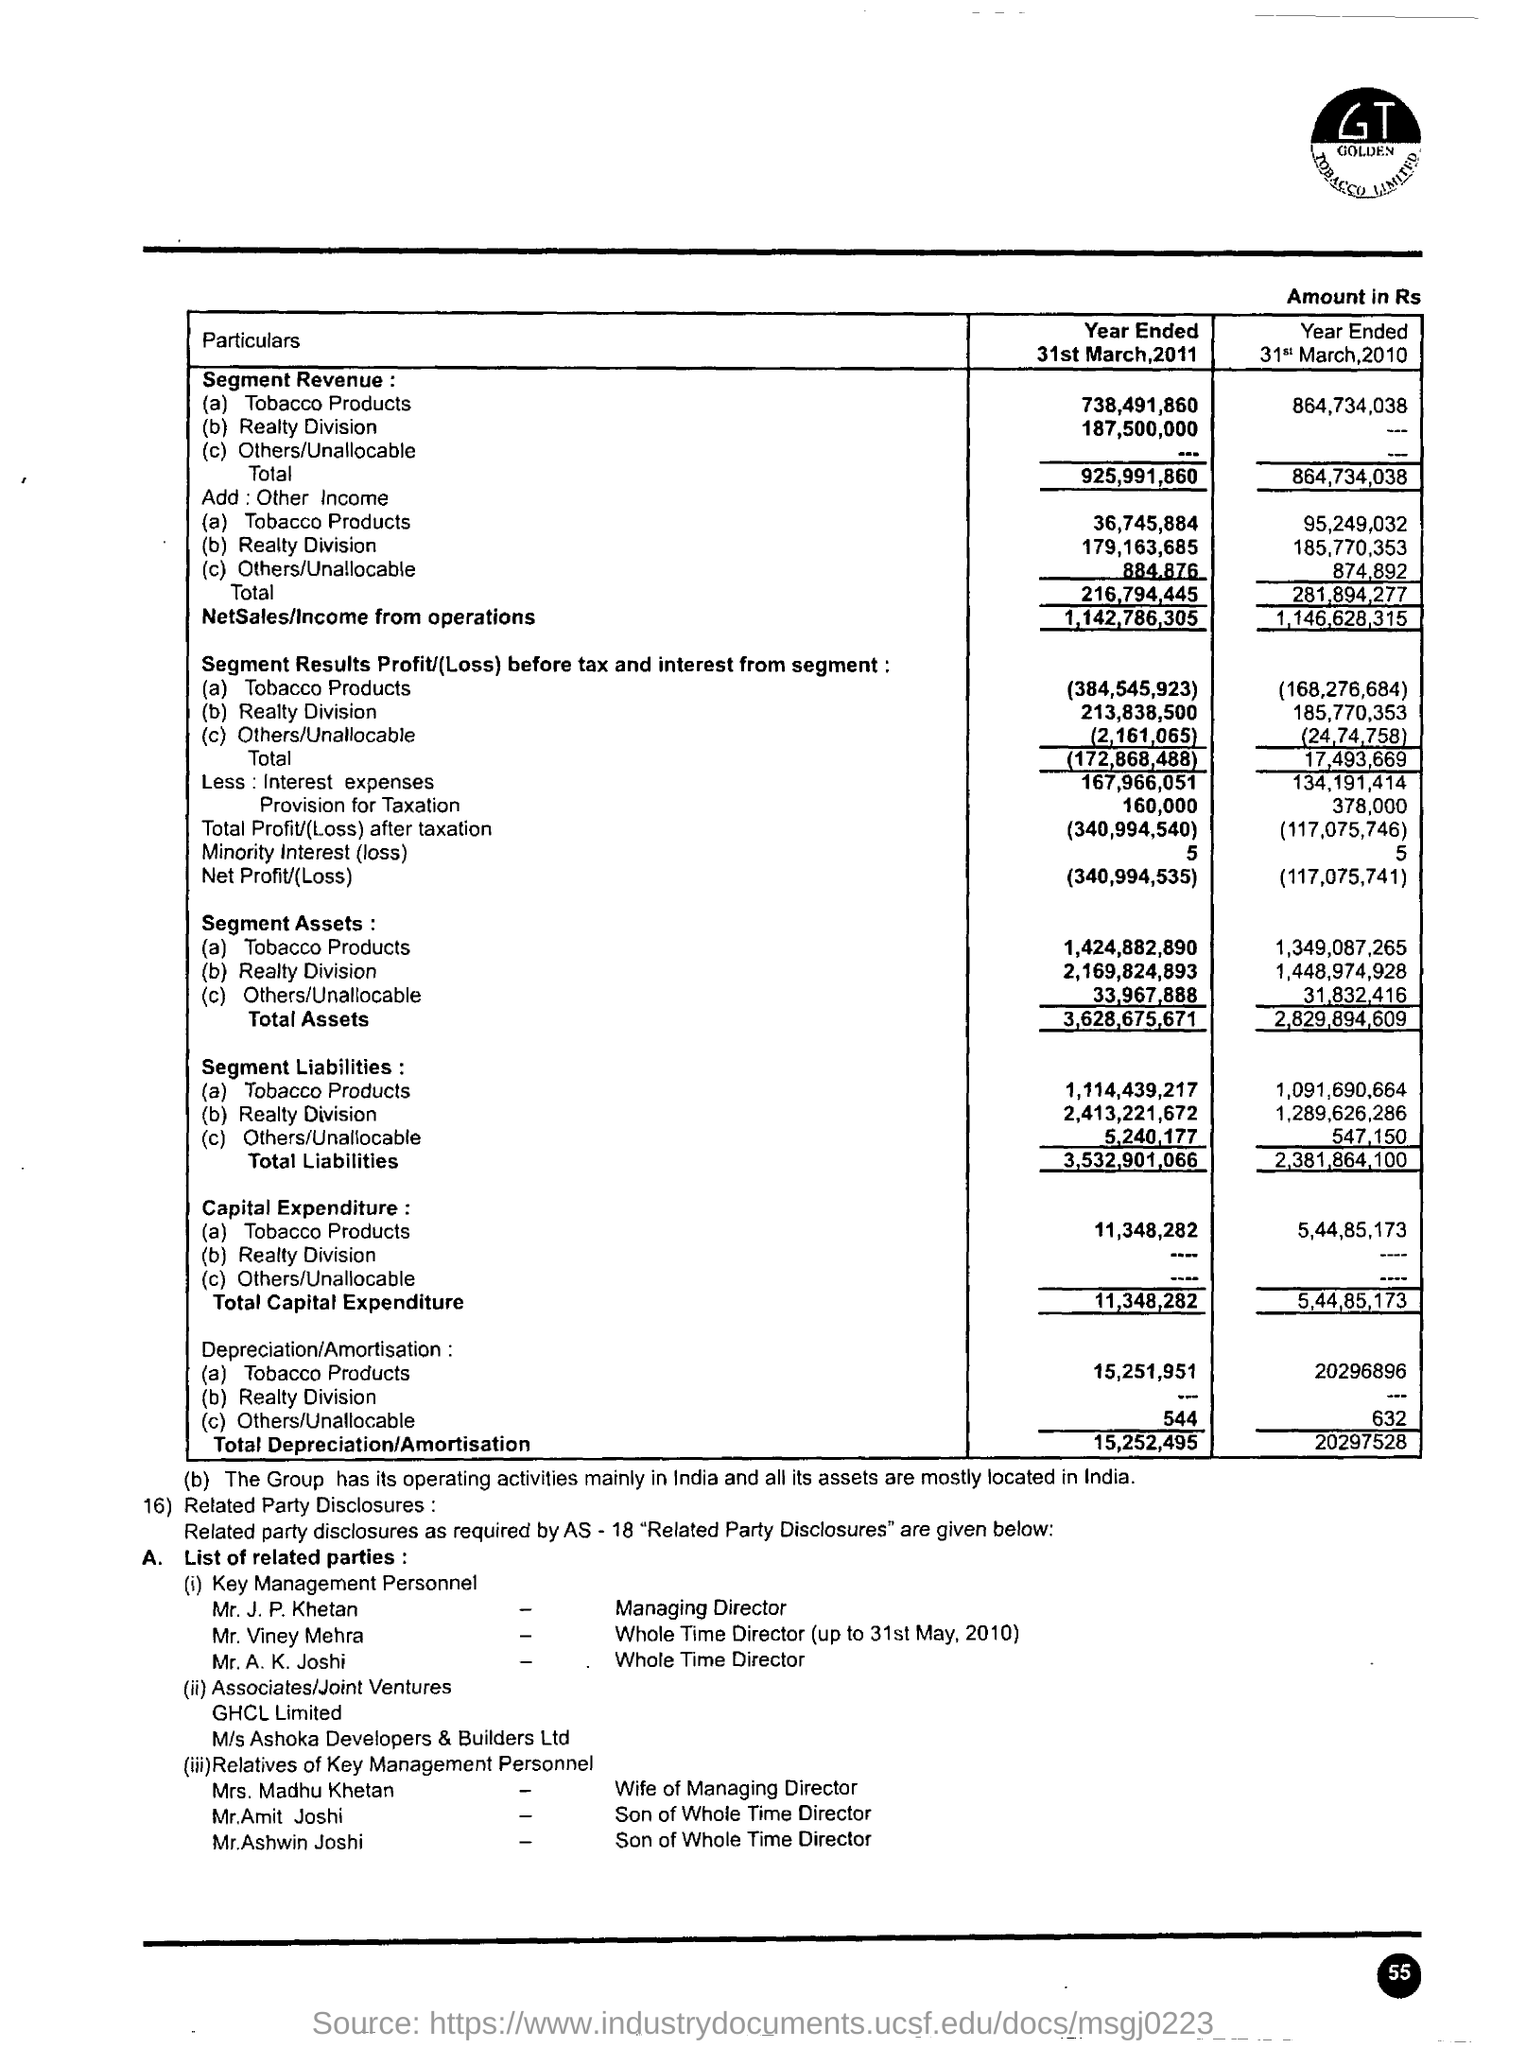Mention a couple of crucial points in this snapshot. The net sales or income from operations for the year ended March 31, 2010, was 1,146,628,315. The individual who holds the position of Managing Director is Mr. J. P. Khetan. The total depreciation/amortization for the year ended March 31, 2010, is 202,975.28. Mr. Viney Mehra served as the Whole-time Director of the company up until May 31, 2010. The total depreciation/amortisation for the year ended on 31st March, 2011, was 15,252,495. 